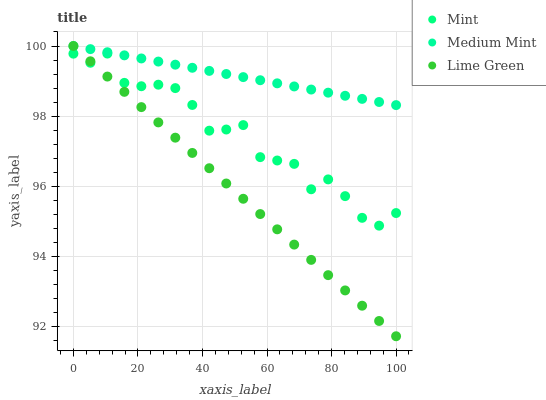Does Lime Green have the minimum area under the curve?
Answer yes or no. Yes. Does Medium Mint have the maximum area under the curve?
Answer yes or no. Yes. Does Mint have the minimum area under the curve?
Answer yes or no. No. Does Mint have the maximum area under the curve?
Answer yes or no. No. Is Medium Mint the smoothest?
Answer yes or no. Yes. Is Mint the roughest?
Answer yes or no. Yes. Is Lime Green the smoothest?
Answer yes or no. No. Is Lime Green the roughest?
Answer yes or no. No. Does Lime Green have the lowest value?
Answer yes or no. Yes. Does Mint have the lowest value?
Answer yes or no. No. Does Lime Green have the highest value?
Answer yes or no. Yes. Does Mint have the highest value?
Answer yes or no. No. Is Mint less than Medium Mint?
Answer yes or no. Yes. Is Medium Mint greater than Mint?
Answer yes or no. Yes. Does Medium Mint intersect Lime Green?
Answer yes or no. Yes. Is Medium Mint less than Lime Green?
Answer yes or no. No. Is Medium Mint greater than Lime Green?
Answer yes or no. No. Does Mint intersect Medium Mint?
Answer yes or no. No. 